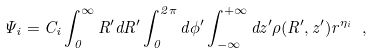Convert formula to latex. <formula><loc_0><loc_0><loc_500><loc_500>\Psi _ { i } = C _ { i } \int _ { 0 } ^ { \infty } { R ^ { \prime } d R ^ { \prime } \int _ { 0 } ^ { 2 \pi } { d \phi ^ { \prime } \int _ { - \infty } ^ { + \infty } { d z ^ { \prime } \rho ( R ^ { \prime } , z ^ { \prime } ) r ^ { \eta _ { i } } } } } \ ,</formula> 